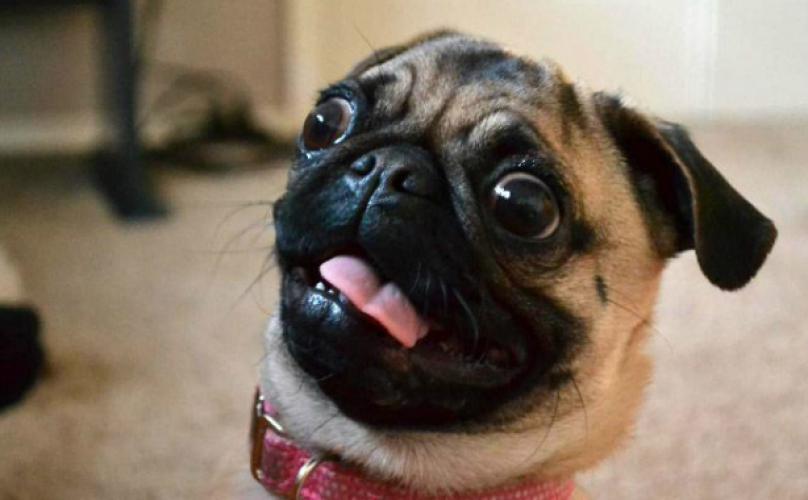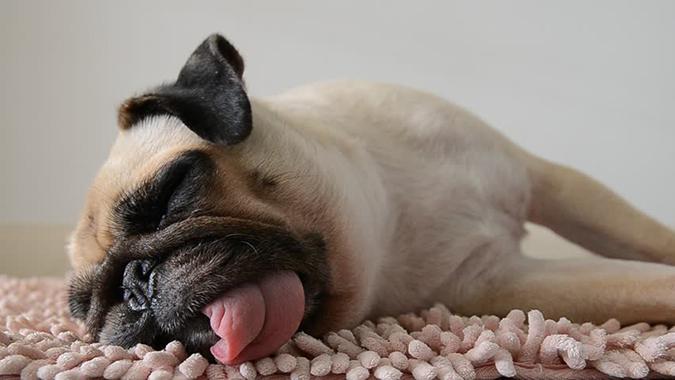The first image is the image on the left, the second image is the image on the right. Considering the images on both sides, is "The pug in the right image is posed with head and body facing forward, and with his front paws extended and farther apart than its body width." valid? Answer yes or no. No. The first image is the image on the left, the second image is the image on the right. Examine the images to the left and right. Is the description "One dog is wearing a dog collar." accurate? Answer yes or no. Yes. 